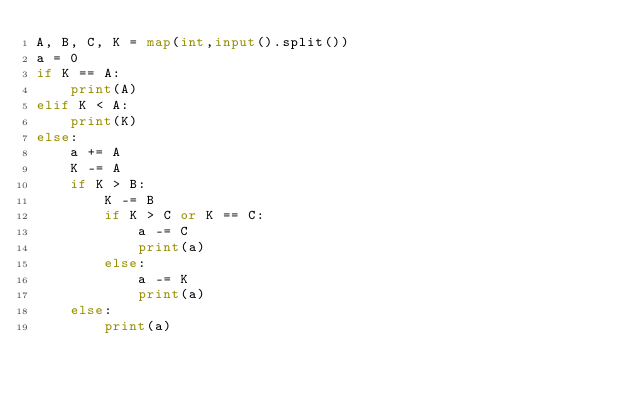Convert code to text. <code><loc_0><loc_0><loc_500><loc_500><_Python_>A, B, C, K = map(int,input().split())
a = 0
if K == A:
    print(A)
elif K < A:
    print(K)
else:
    a += A
    K -= A
    if K > B:
        K -= B
        if K > C or K == C:
            a -= C
            print(a)
        else:
            a -= K
            print(a)
    else:
        print(a)</code> 